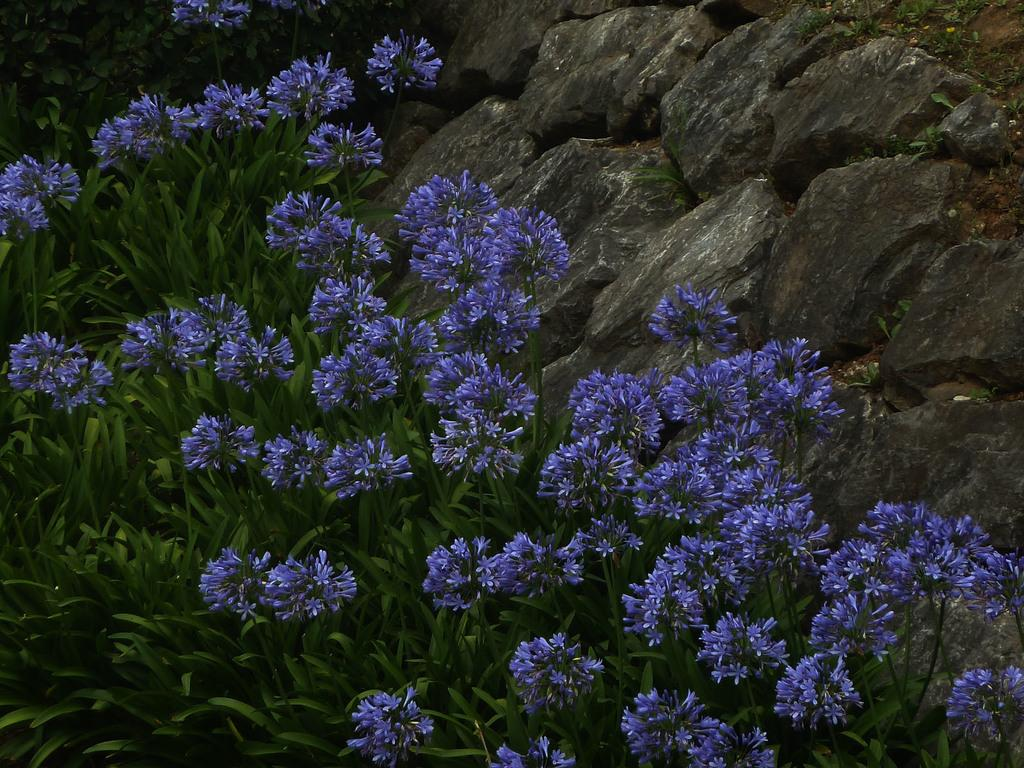What color are the flowers in the image? The flowers in the image are purple. What are the flowers growing on? The flowers are on plants. What can be seen to the right in the image? There are rocks visible to the right in the image. What type of sound can be heard coming from the zoo in the image? There is no zoo present in the image, so it's not possible to determine what, if any, sounds might be heard. 